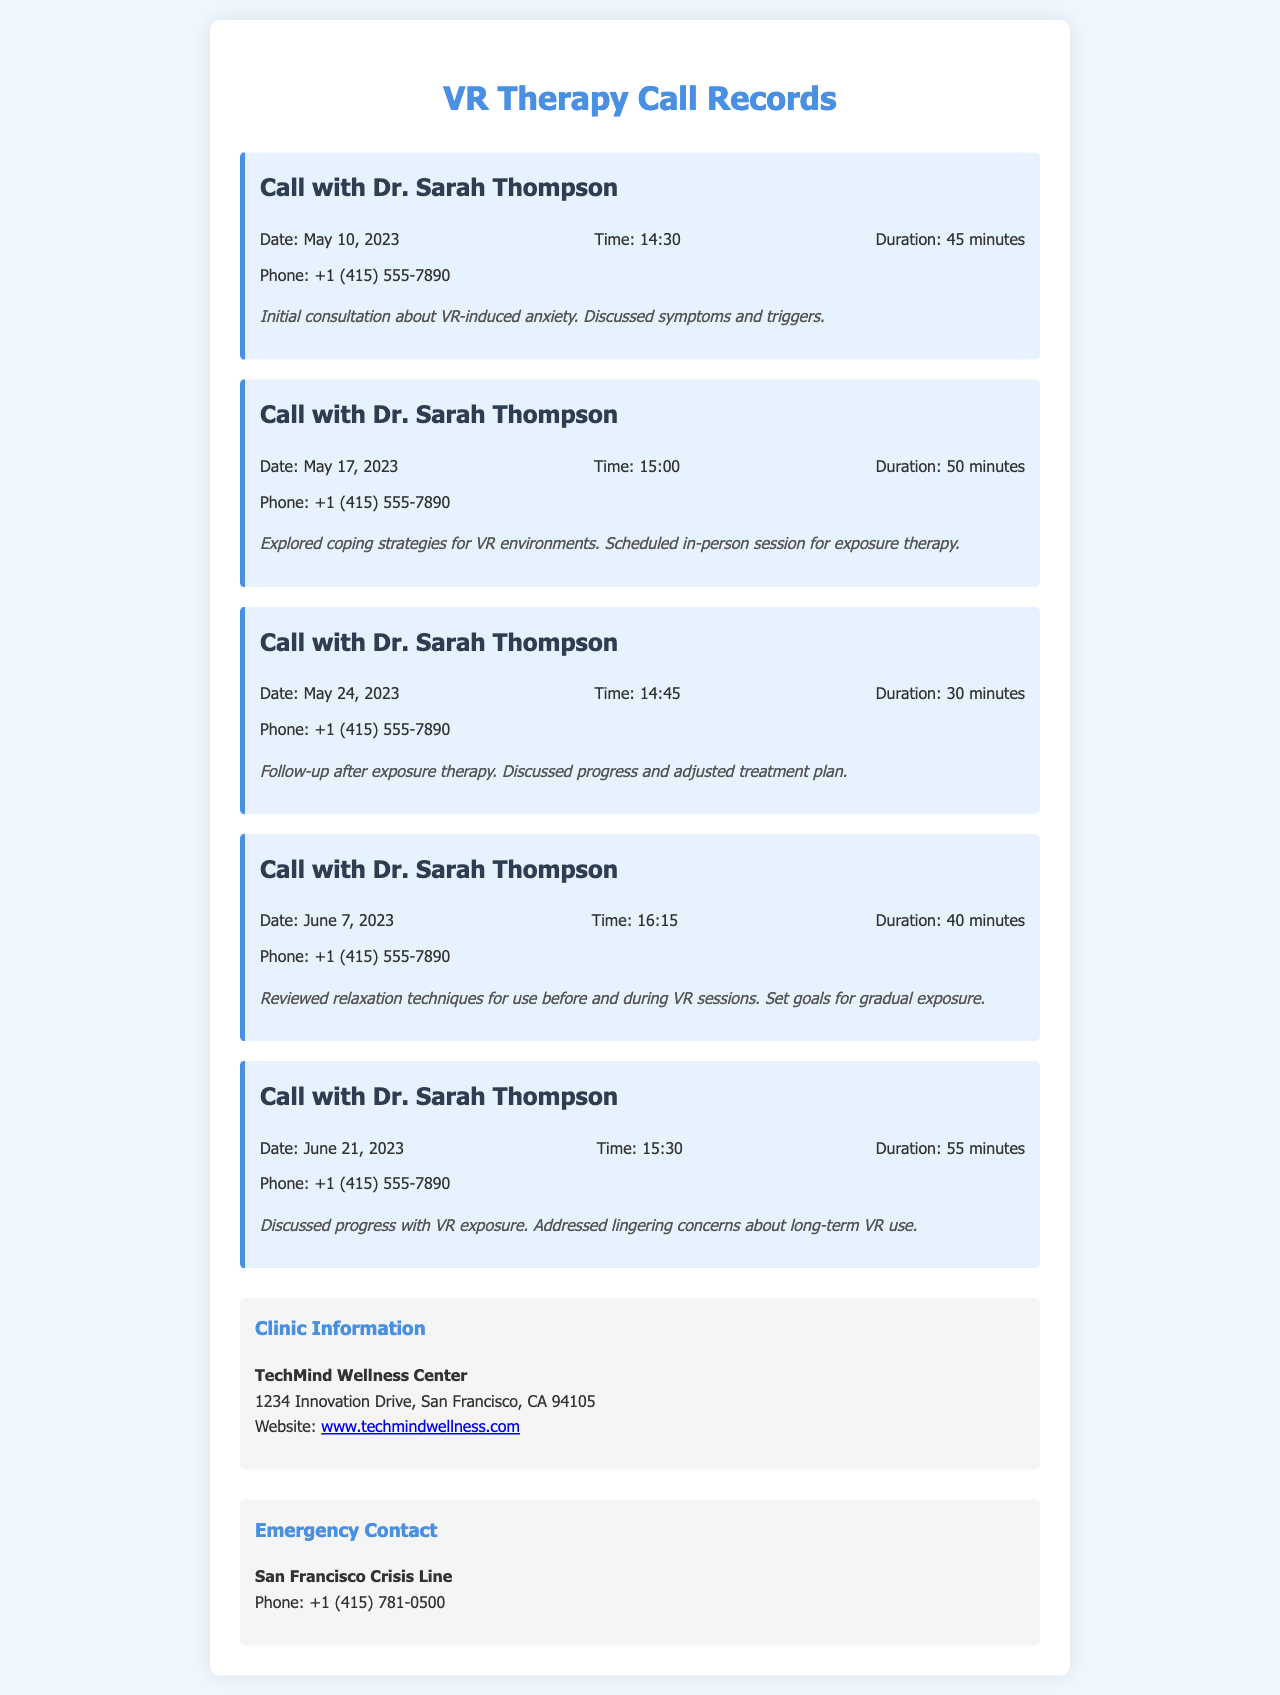what is the name of the mental health professional? The name mentioned in the document as the mental health professional is Dr. Sarah Thompson.
Answer: Dr. Sarah Thompson how many calls were recorded? The document lists a total of five calls with the mental health professional.
Answer: 5 what was the duration of the call on May 24, 2023? The duration for the call on that date is provided in the document as 30 minutes.
Answer: 30 minutes what is the phone number of the mental health professional's clinic? The document includes the contact number for the calls as +1 (415) 555-7890.
Answer: +1 (415) 555-7890 which strategy was explored during the call on May 17, 2023? The call on that date specifically explored coping strategies for VR environments.
Answer: coping strategies for VR environments what was discussed in the call on June 21, 2023? The document states that the call discussed progress with VR exposure and lingering concerns about long-term VR use.
Answer: progress with VR exposure how long did the call on June 7, 2023 last? The document details that the call on this date lasted for 40 minutes.
Answer: 40 minutes who should be contacted in case of an emergency? The emergency contact listed in the document is the San Francisco Crisis Line.
Answer: San Francisco Crisis Line 